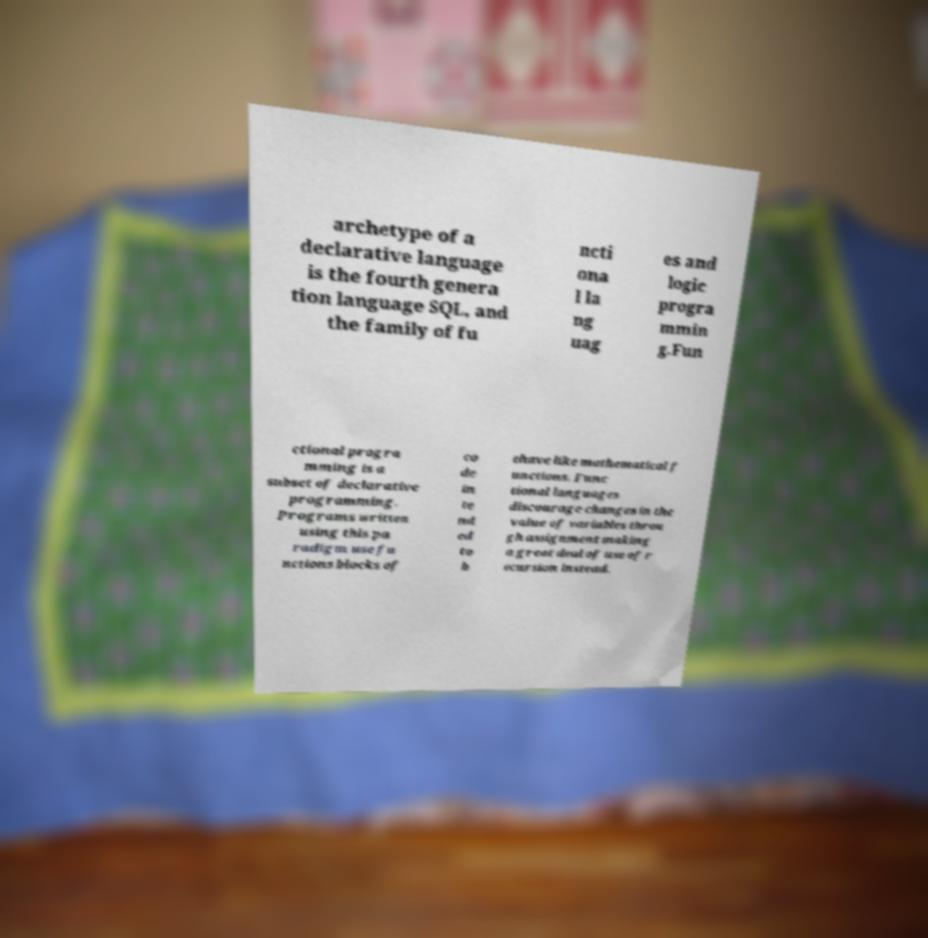What messages or text are displayed in this image? I need them in a readable, typed format. archetype of a declarative language is the fourth genera tion language SQL, and the family of fu ncti ona l la ng uag es and logic progra mmin g.Fun ctional progra mming is a subset of declarative programming. Programs written using this pa radigm use fu nctions blocks of co de in te nd ed to b ehave like mathematical f unctions. Func tional languages discourage changes in the value of variables throu gh assignment making a great deal of use of r ecursion instead. 